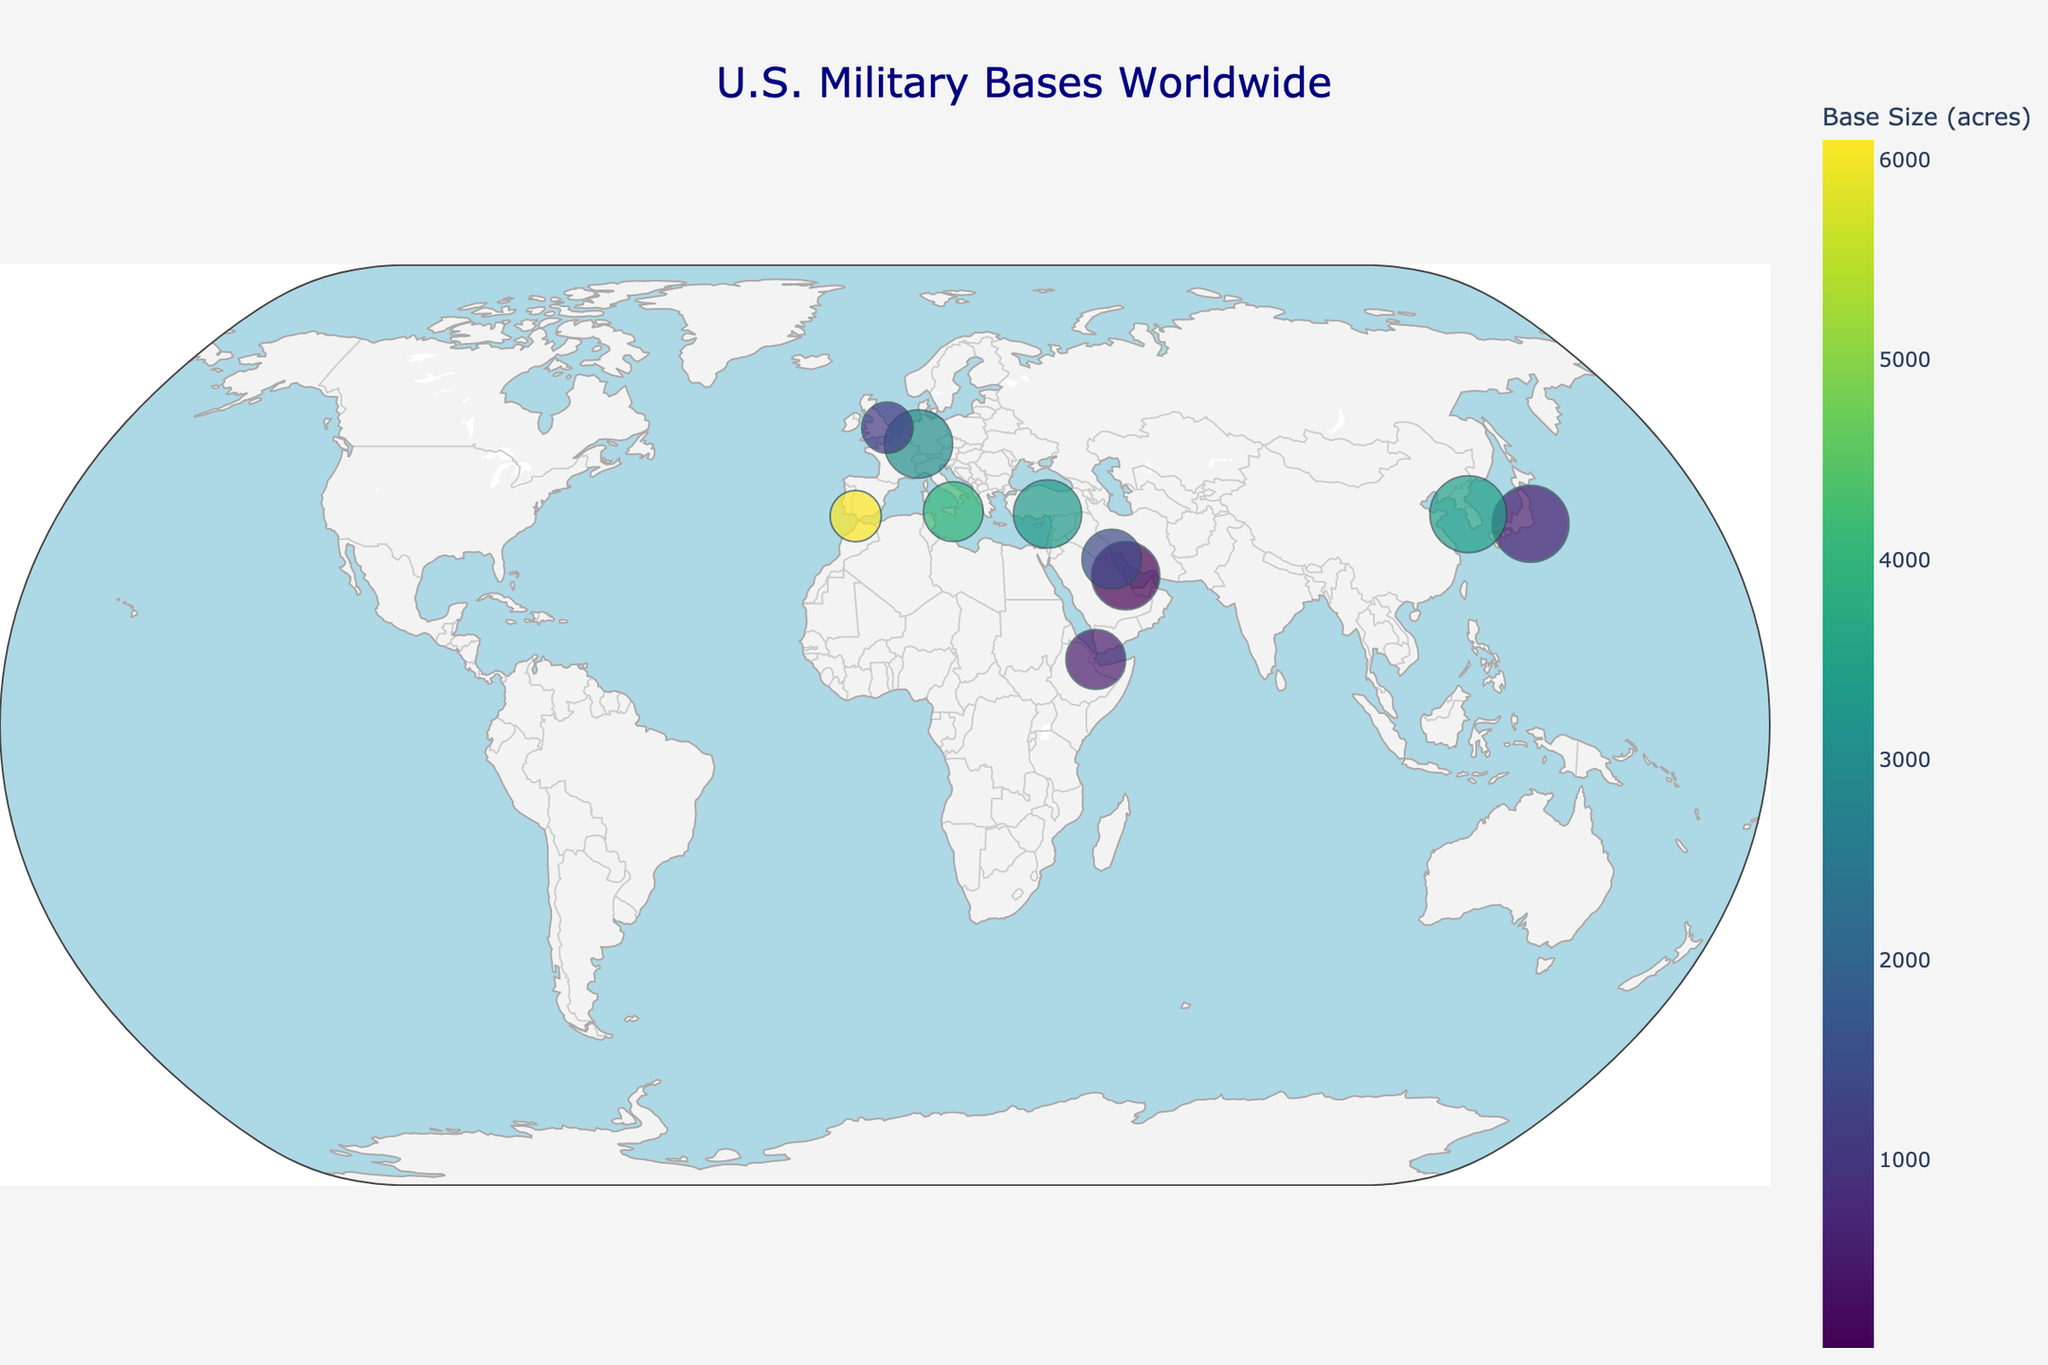What's the title of the plot? The title of the plot is located at the top center of the figure and is used to give a brief description of what the plot represents. In this figure, it is clearly stated.
Answer: U.S. Military Bases Worldwide How many U.S. military bases are shown in the plot? By counting the number of markers (points) on the plot, we can ascertain the number of U.S. military bases displayed.
Answer: 10 Which base is the largest in terms of size (acres)? By observing the color of the markers and the data provided, we can see that the Naval Station Rota in Spain is associated with the largest marker size in terms of acres.
Answer: Naval Station Rota What is the strategic importance level of Yokosuka Naval Base in Japan? The figure includes information on the strategic importance of each base, which can be seen by hovering over the Yokosuka Naval Base marker.
Answer: 9 Which base has the smallest strategic importance level? By comparing the strategic importance levels provided in the hover text for each base, we can identify the base with the smallest value.
Answer: RAF Lakenheath What is the combined size (acres) of the bases in Europe? The bases in Europe are Ramstein Air Base, Naval Air Station Sigonella, RAF Lakenheath, and Naval Station Rota. Summing up their sizes (3000 + 4100 + 1087 + 6100) gives the total acreage.
Answer: 14287 What is the difference in the size between Camp Humphreys in South Korea and Incirlik Air Base in Turkey? The size of Camp Humphreys is 3454 acres and the size of Incirlik Air Base is 3300 acres. The difference is found by subtracting the size of the smaller base from the larger base (3454 - 3300).
Answer: 154 Which base in the Middle East has the highest strategic importance? The bases in the Middle East include Naval Support Activity Bahrain, Incirlik Air Base, and Camp Arifjan. By comparing their strategic importance levels (8, 8, and 7), we see that Naval Support Activity Bahrain and Incirlik Air Base both have the highest level.
Answer: Naval Support Activity Bahrain and Incirlik Air Base Are there more bases in Asia or Europe shown in this figure? To answer this, we count the number of bases in each region. There are 2 in Asia (Yokosuka Naval Base, Camp Humphreys) and 4 in Europe (Ramstein Air Base, Naval Air Station Sigonella, RAF Lakenheath, Naval Station Rota).
Answer: Europe How does the marker size relate to the strategic importance of the bases? The marker size on the figure is scaled according to the strategic importance of each base, with larger markers indicating higher strategic importance. This is confirmed by looking at the marker size details.
Answer: Larger markers indicate higher strategic importance 